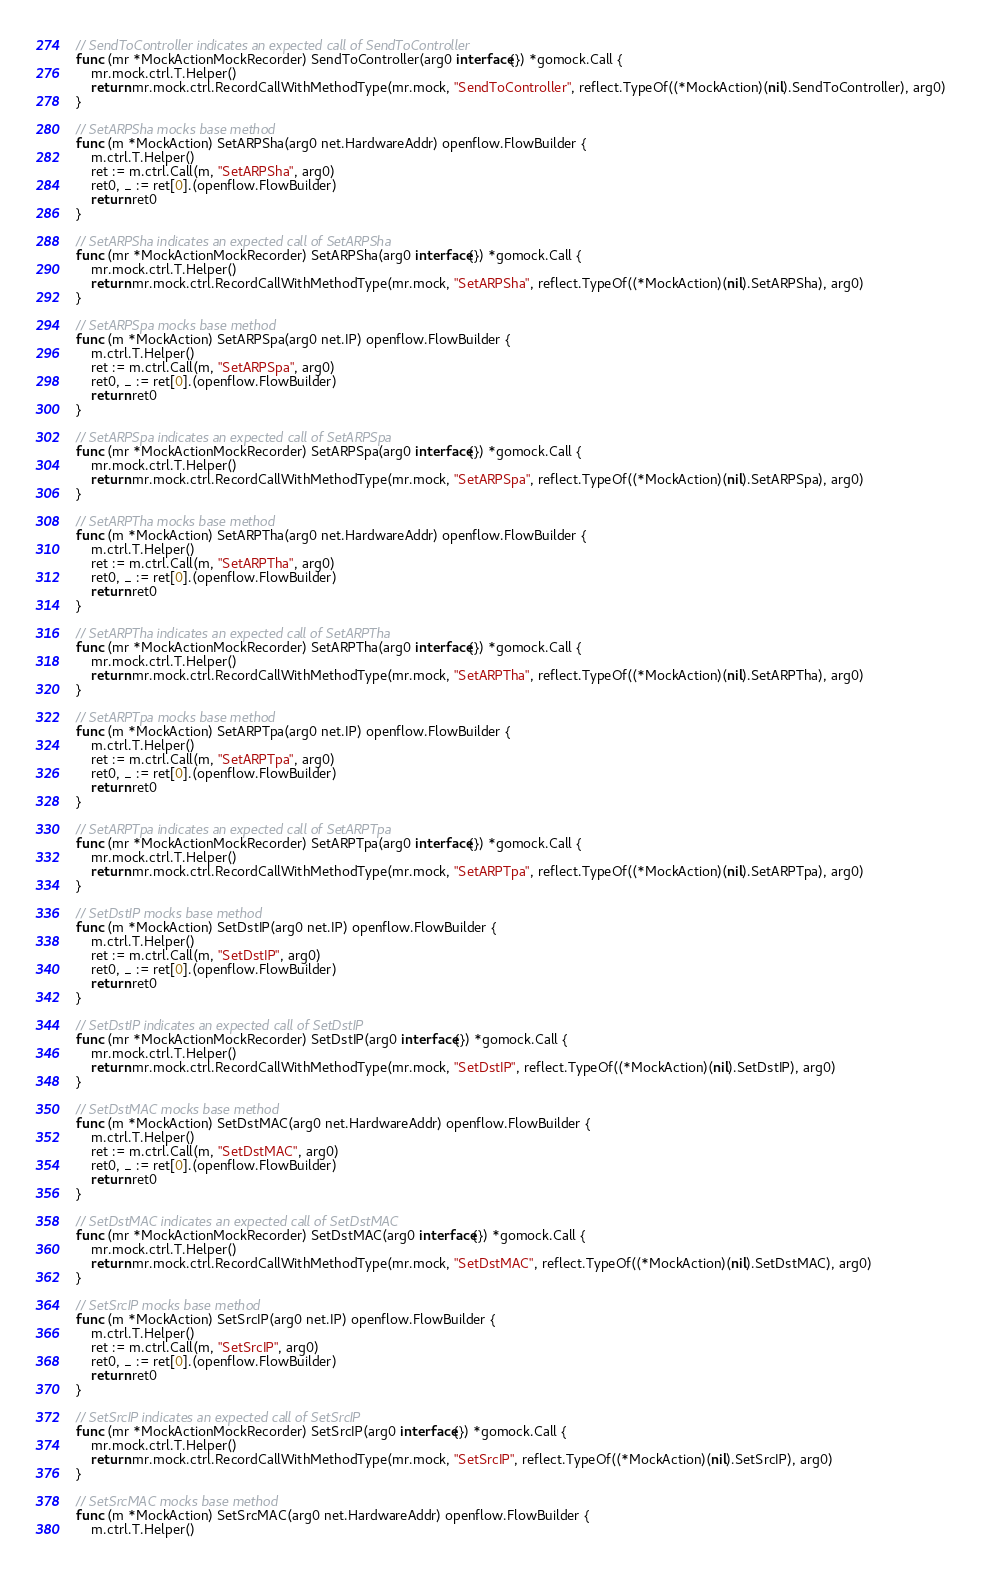Convert code to text. <code><loc_0><loc_0><loc_500><loc_500><_Go_>
// SendToController indicates an expected call of SendToController
func (mr *MockActionMockRecorder) SendToController(arg0 interface{}) *gomock.Call {
	mr.mock.ctrl.T.Helper()
	return mr.mock.ctrl.RecordCallWithMethodType(mr.mock, "SendToController", reflect.TypeOf((*MockAction)(nil).SendToController), arg0)
}

// SetARPSha mocks base method
func (m *MockAction) SetARPSha(arg0 net.HardwareAddr) openflow.FlowBuilder {
	m.ctrl.T.Helper()
	ret := m.ctrl.Call(m, "SetARPSha", arg0)
	ret0, _ := ret[0].(openflow.FlowBuilder)
	return ret0
}

// SetARPSha indicates an expected call of SetARPSha
func (mr *MockActionMockRecorder) SetARPSha(arg0 interface{}) *gomock.Call {
	mr.mock.ctrl.T.Helper()
	return mr.mock.ctrl.RecordCallWithMethodType(mr.mock, "SetARPSha", reflect.TypeOf((*MockAction)(nil).SetARPSha), arg0)
}

// SetARPSpa mocks base method
func (m *MockAction) SetARPSpa(arg0 net.IP) openflow.FlowBuilder {
	m.ctrl.T.Helper()
	ret := m.ctrl.Call(m, "SetARPSpa", arg0)
	ret0, _ := ret[0].(openflow.FlowBuilder)
	return ret0
}

// SetARPSpa indicates an expected call of SetARPSpa
func (mr *MockActionMockRecorder) SetARPSpa(arg0 interface{}) *gomock.Call {
	mr.mock.ctrl.T.Helper()
	return mr.mock.ctrl.RecordCallWithMethodType(mr.mock, "SetARPSpa", reflect.TypeOf((*MockAction)(nil).SetARPSpa), arg0)
}

// SetARPTha mocks base method
func (m *MockAction) SetARPTha(arg0 net.HardwareAddr) openflow.FlowBuilder {
	m.ctrl.T.Helper()
	ret := m.ctrl.Call(m, "SetARPTha", arg0)
	ret0, _ := ret[0].(openflow.FlowBuilder)
	return ret0
}

// SetARPTha indicates an expected call of SetARPTha
func (mr *MockActionMockRecorder) SetARPTha(arg0 interface{}) *gomock.Call {
	mr.mock.ctrl.T.Helper()
	return mr.mock.ctrl.RecordCallWithMethodType(mr.mock, "SetARPTha", reflect.TypeOf((*MockAction)(nil).SetARPTha), arg0)
}

// SetARPTpa mocks base method
func (m *MockAction) SetARPTpa(arg0 net.IP) openflow.FlowBuilder {
	m.ctrl.T.Helper()
	ret := m.ctrl.Call(m, "SetARPTpa", arg0)
	ret0, _ := ret[0].(openflow.FlowBuilder)
	return ret0
}

// SetARPTpa indicates an expected call of SetARPTpa
func (mr *MockActionMockRecorder) SetARPTpa(arg0 interface{}) *gomock.Call {
	mr.mock.ctrl.T.Helper()
	return mr.mock.ctrl.RecordCallWithMethodType(mr.mock, "SetARPTpa", reflect.TypeOf((*MockAction)(nil).SetARPTpa), arg0)
}

// SetDstIP mocks base method
func (m *MockAction) SetDstIP(arg0 net.IP) openflow.FlowBuilder {
	m.ctrl.T.Helper()
	ret := m.ctrl.Call(m, "SetDstIP", arg0)
	ret0, _ := ret[0].(openflow.FlowBuilder)
	return ret0
}

// SetDstIP indicates an expected call of SetDstIP
func (mr *MockActionMockRecorder) SetDstIP(arg0 interface{}) *gomock.Call {
	mr.mock.ctrl.T.Helper()
	return mr.mock.ctrl.RecordCallWithMethodType(mr.mock, "SetDstIP", reflect.TypeOf((*MockAction)(nil).SetDstIP), arg0)
}

// SetDstMAC mocks base method
func (m *MockAction) SetDstMAC(arg0 net.HardwareAddr) openflow.FlowBuilder {
	m.ctrl.T.Helper()
	ret := m.ctrl.Call(m, "SetDstMAC", arg0)
	ret0, _ := ret[0].(openflow.FlowBuilder)
	return ret0
}

// SetDstMAC indicates an expected call of SetDstMAC
func (mr *MockActionMockRecorder) SetDstMAC(arg0 interface{}) *gomock.Call {
	mr.mock.ctrl.T.Helper()
	return mr.mock.ctrl.RecordCallWithMethodType(mr.mock, "SetDstMAC", reflect.TypeOf((*MockAction)(nil).SetDstMAC), arg0)
}

// SetSrcIP mocks base method
func (m *MockAction) SetSrcIP(arg0 net.IP) openflow.FlowBuilder {
	m.ctrl.T.Helper()
	ret := m.ctrl.Call(m, "SetSrcIP", arg0)
	ret0, _ := ret[0].(openflow.FlowBuilder)
	return ret0
}

// SetSrcIP indicates an expected call of SetSrcIP
func (mr *MockActionMockRecorder) SetSrcIP(arg0 interface{}) *gomock.Call {
	mr.mock.ctrl.T.Helper()
	return mr.mock.ctrl.RecordCallWithMethodType(mr.mock, "SetSrcIP", reflect.TypeOf((*MockAction)(nil).SetSrcIP), arg0)
}

// SetSrcMAC mocks base method
func (m *MockAction) SetSrcMAC(arg0 net.HardwareAddr) openflow.FlowBuilder {
	m.ctrl.T.Helper()</code> 